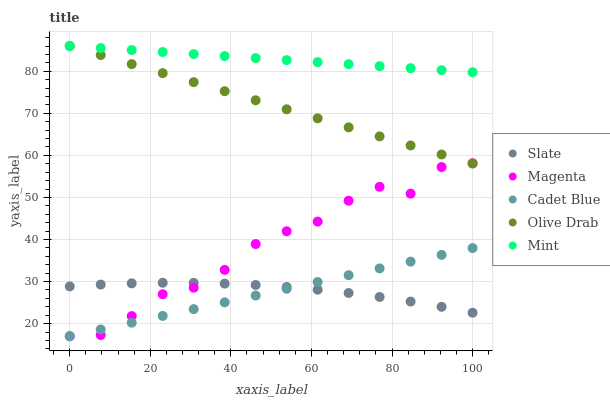Does Cadet Blue have the minimum area under the curve?
Answer yes or no. Yes. Does Mint have the maximum area under the curve?
Answer yes or no. Yes. Does Mint have the minimum area under the curve?
Answer yes or no. No. Does Cadet Blue have the maximum area under the curve?
Answer yes or no. No. Is Cadet Blue the smoothest?
Answer yes or no. Yes. Is Magenta the roughest?
Answer yes or no. Yes. Is Mint the smoothest?
Answer yes or no. No. Is Mint the roughest?
Answer yes or no. No. Does Cadet Blue have the lowest value?
Answer yes or no. Yes. Does Mint have the lowest value?
Answer yes or no. No. Does Olive Drab have the highest value?
Answer yes or no. Yes. Does Cadet Blue have the highest value?
Answer yes or no. No. Is Cadet Blue less than Olive Drab?
Answer yes or no. Yes. Is Mint greater than Slate?
Answer yes or no. Yes. Does Mint intersect Olive Drab?
Answer yes or no. Yes. Is Mint less than Olive Drab?
Answer yes or no. No. Is Mint greater than Olive Drab?
Answer yes or no. No. Does Cadet Blue intersect Olive Drab?
Answer yes or no. No. 